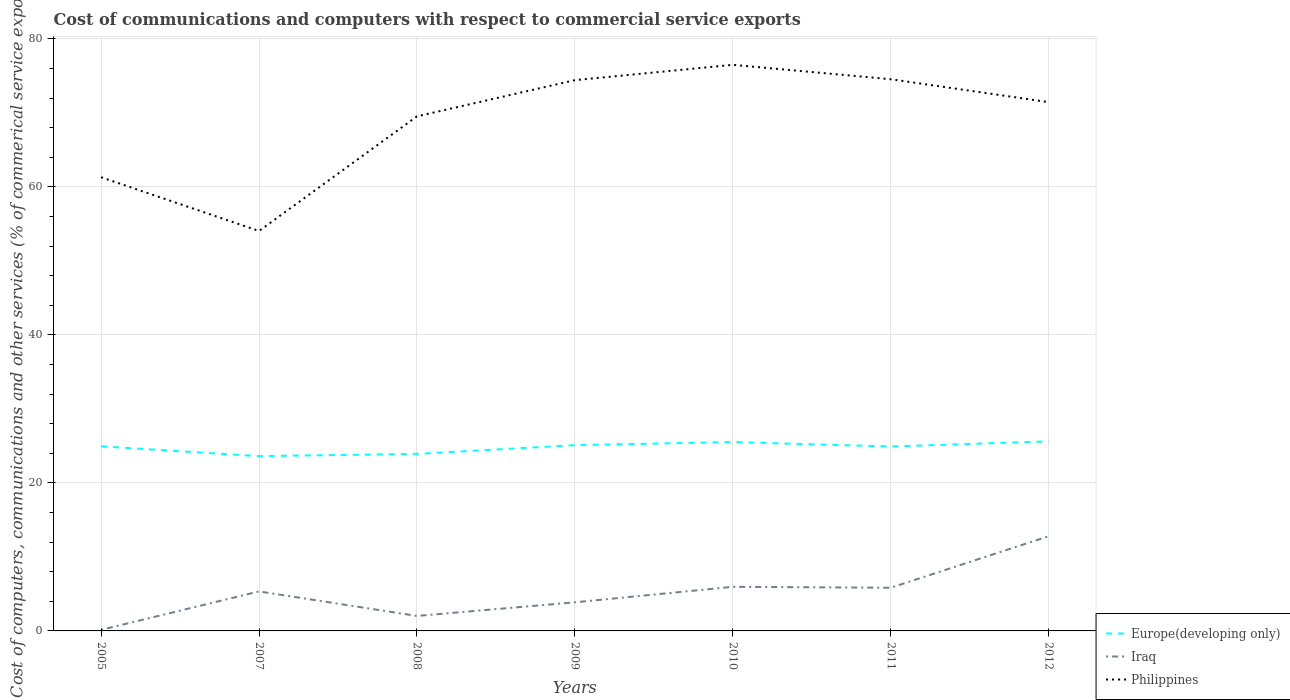Across all years, what is the maximum cost of communications and computers in Philippines?
Offer a very short reply. 54.05. In which year was the cost of communications and computers in Iraq maximum?
Ensure brevity in your answer.  2005. What is the total cost of communications and computers in Iraq in the graph?
Your answer should be compact. -6.96. What is the difference between the highest and the second highest cost of communications and computers in Europe(developing only)?
Keep it short and to the point. 2. Are the values on the major ticks of Y-axis written in scientific E-notation?
Offer a very short reply. No. Does the graph contain any zero values?
Provide a short and direct response. No. How many legend labels are there?
Ensure brevity in your answer.  3. How are the legend labels stacked?
Provide a short and direct response. Vertical. What is the title of the graph?
Offer a terse response. Cost of communications and computers with respect to commercial service exports. Does "Singapore" appear as one of the legend labels in the graph?
Your answer should be very brief. No. What is the label or title of the Y-axis?
Keep it short and to the point. Cost of computers, communications and other services (% of commerical service exports). What is the Cost of computers, communications and other services (% of commerical service exports) in Europe(developing only) in 2005?
Give a very brief answer. 24.95. What is the Cost of computers, communications and other services (% of commerical service exports) in Iraq in 2005?
Provide a short and direct response. 0.14. What is the Cost of computers, communications and other services (% of commerical service exports) in Philippines in 2005?
Your answer should be compact. 61.31. What is the Cost of computers, communications and other services (% of commerical service exports) in Europe(developing only) in 2007?
Offer a very short reply. 23.62. What is the Cost of computers, communications and other services (% of commerical service exports) in Iraq in 2007?
Give a very brief answer. 5.34. What is the Cost of computers, communications and other services (% of commerical service exports) in Philippines in 2007?
Offer a terse response. 54.05. What is the Cost of computers, communications and other services (% of commerical service exports) of Europe(developing only) in 2008?
Ensure brevity in your answer.  23.93. What is the Cost of computers, communications and other services (% of commerical service exports) in Iraq in 2008?
Your answer should be compact. 2.03. What is the Cost of computers, communications and other services (% of commerical service exports) of Philippines in 2008?
Your answer should be very brief. 69.54. What is the Cost of computers, communications and other services (% of commerical service exports) in Europe(developing only) in 2009?
Offer a very short reply. 25.11. What is the Cost of computers, communications and other services (% of commerical service exports) in Iraq in 2009?
Your answer should be compact. 3.87. What is the Cost of computers, communications and other services (% of commerical service exports) in Philippines in 2009?
Offer a terse response. 74.43. What is the Cost of computers, communications and other services (% of commerical service exports) of Europe(developing only) in 2010?
Provide a succinct answer. 25.52. What is the Cost of computers, communications and other services (% of commerical service exports) in Iraq in 2010?
Your response must be concise. 5.96. What is the Cost of computers, communications and other services (% of commerical service exports) in Philippines in 2010?
Offer a terse response. 76.5. What is the Cost of computers, communications and other services (% of commerical service exports) in Europe(developing only) in 2011?
Make the answer very short. 24.93. What is the Cost of computers, communications and other services (% of commerical service exports) in Iraq in 2011?
Give a very brief answer. 5.84. What is the Cost of computers, communications and other services (% of commerical service exports) of Philippines in 2011?
Give a very brief answer. 74.56. What is the Cost of computers, communications and other services (% of commerical service exports) in Europe(developing only) in 2012?
Your response must be concise. 25.62. What is the Cost of computers, communications and other services (% of commerical service exports) in Iraq in 2012?
Give a very brief answer. 12.8. What is the Cost of computers, communications and other services (% of commerical service exports) in Philippines in 2012?
Your answer should be very brief. 71.46. Across all years, what is the maximum Cost of computers, communications and other services (% of commerical service exports) of Europe(developing only)?
Your response must be concise. 25.62. Across all years, what is the maximum Cost of computers, communications and other services (% of commerical service exports) of Iraq?
Your answer should be very brief. 12.8. Across all years, what is the maximum Cost of computers, communications and other services (% of commerical service exports) in Philippines?
Your response must be concise. 76.5. Across all years, what is the minimum Cost of computers, communications and other services (% of commerical service exports) in Europe(developing only)?
Make the answer very short. 23.62. Across all years, what is the minimum Cost of computers, communications and other services (% of commerical service exports) in Iraq?
Offer a terse response. 0.14. Across all years, what is the minimum Cost of computers, communications and other services (% of commerical service exports) of Philippines?
Offer a very short reply. 54.05. What is the total Cost of computers, communications and other services (% of commerical service exports) of Europe(developing only) in the graph?
Your answer should be very brief. 173.67. What is the total Cost of computers, communications and other services (% of commerical service exports) in Iraq in the graph?
Ensure brevity in your answer.  35.97. What is the total Cost of computers, communications and other services (% of commerical service exports) of Philippines in the graph?
Offer a very short reply. 481.86. What is the difference between the Cost of computers, communications and other services (% of commerical service exports) of Europe(developing only) in 2005 and that in 2007?
Offer a terse response. 1.33. What is the difference between the Cost of computers, communications and other services (% of commerical service exports) of Iraq in 2005 and that in 2007?
Keep it short and to the point. -5.19. What is the difference between the Cost of computers, communications and other services (% of commerical service exports) of Philippines in 2005 and that in 2007?
Keep it short and to the point. 7.27. What is the difference between the Cost of computers, communications and other services (% of commerical service exports) in Europe(developing only) in 2005 and that in 2008?
Offer a terse response. 1.02. What is the difference between the Cost of computers, communications and other services (% of commerical service exports) of Iraq in 2005 and that in 2008?
Your answer should be very brief. -1.88. What is the difference between the Cost of computers, communications and other services (% of commerical service exports) of Philippines in 2005 and that in 2008?
Offer a terse response. -8.23. What is the difference between the Cost of computers, communications and other services (% of commerical service exports) of Europe(developing only) in 2005 and that in 2009?
Ensure brevity in your answer.  -0.16. What is the difference between the Cost of computers, communications and other services (% of commerical service exports) in Iraq in 2005 and that in 2009?
Your answer should be very brief. -3.72. What is the difference between the Cost of computers, communications and other services (% of commerical service exports) in Philippines in 2005 and that in 2009?
Your answer should be very brief. -13.12. What is the difference between the Cost of computers, communications and other services (% of commerical service exports) of Europe(developing only) in 2005 and that in 2010?
Your answer should be compact. -0.58. What is the difference between the Cost of computers, communications and other services (% of commerical service exports) in Iraq in 2005 and that in 2010?
Keep it short and to the point. -5.82. What is the difference between the Cost of computers, communications and other services (% of commerical service exports) of Philippines in 2005 and that in 2010?
Keep it short and to the point. -15.19. What is the difference between the Cost of computers, communications and other services (% of commerical service exports) of Europe(developing only) in 2005 and that in 2011?
Your answer should be compact. 0.02. What is the difference between the Cost of computers, communications and other services (% of commerical service exports) of Iraq in 2005 and that in 2011?
Give a very brief answer. -5.69. What is the difference between the Cost of computers, communications and other services (% of commerical service exports) in Philippines in 2005 and that in 2011?
Provide a short and direct response. -13.24. What is the difference between the Cost of computers, communications and other services (% of commerical service exports) in Europe(developing only) in 2005 and that in 2012?
Give a very brief answer. -0.67. What is the difference between the Cost of computers, communications and other services (% of commerical service exports) in Iraq in 2005 and that in 2012?
Provide a succinct answer. -12.65. What is the difference between the Cost of computers, communications and other services (% of commerical service exports) of Philippines in 2005 and that in 2012?
Offer a terse response. -10.15. What is the difference between the Cost of computers, communications and other services (% of commerical service exports) in Europe(developing only) in 2007 and that in 2008?
Give a very brief answer. -0.31. What is the difference between the Cost of computers, communications and other services (% of commerical service exports) of Iraq in 2007 and that in 2008?
Give a very brief answer. 3.31. What is the difference between the Cost of computers, communications and other services (% of commerical service exports) in Philippines in 2007 and that in 2008?
Offer a very short reply. -15.49. What is the difference between the Cost of computers, communications and other services (% of commerical service exports) of Europe(developing only) in 2007 and that in 2009?
Provide a succinct answer. -1.49. What is the difference between the Cost of computers, communications and other services (% of commerical service exports) of Iraq in 2007 and that in 2009?
Offer a terse response. 1.47. What is the difference between the Cost of computers, communications and other services (% of commerical service exports) in Philippines in 2007 and that in 2009?
Give a very brief answer. -20.38. What is the difference between the Cost of computers, communications and other services (% of commerical service exports) of Europe(developing only) in 2007 and that in 2010?
Provide a short and direct response. -1.9. What is the difference between the Cost of computers, communications and other services (% of commerical service exports) in Iraq in 2007 and that in 2010?
Your answer should be compact. -0.62. What is the difference between the Cost of computers, communications and other services (% of commerical service exports) of Philippines in 2007 and that in 2010?
Your answer should be compact. -22.46. What is the difference between the Cost of computers, communications and other services (% of commerical service exports) in Europe(developing only) in 2007 and that in 2011?
Offer a terse response. -1.3. What is the difference between the Cost of computers, communications and other services (% of commerical service exports) of Iraq in 2007 and that in 2011?
Give a very brief answer. -0.5. What is the difference between the Cost of computers, communications and other services (% of commerical service exports) of Philippines in 2007 and that in 2011?
Your response must be concise. -20.51. What is the difference between the Cost of computers, communications and other services (% of commerical service exports) of Europe(developing only) in 2007 and that in 2012?
Make the answer very short. -2. What is the difference between the Cost of computers, communications and other services (% of commerical service exports) of Iraq in 2007 and that in 2012?
Keep it short and to the point. -7.46. What is the difference between the Cost of computers, communications and other services (% of commerical service exports) in Philippines in 2007 and that in 2012?
Your answer should be compact. -17.41. What is the difference between the Cost of computers, communications and other services (% of commerical service exports) of Europe(developing only) in 2008 and that in 2009?
Give a very brief answer. -1.18. What is the difference between the Cost of computers, communications and other services (% of commerical service exports) in Iraq in 2008 and that in 2009?
Make the answer very short. -1.84. What is the difference between the Cost of computers, communications and other services (% of commerical service exports) in Philippines in 2008 and that in 2009?
Make the answer very short. -4.89. What is the difference between the Cost of computers, communications and other services (% of commerical service exports) in Europe(developing only) in 2008 and that in 2010?
Your answer should be very brief. -1.6. What is the difference between the Cost of computers, communications and other services (% of commerical service exports) of Iraq in 2008 and that in 2010?
Provide a succinct answer. -3.94. What is the difference between the Cost of computers, communications and other services (% of commerical service exports) in Philippines in 2008 and that in 2010?
Offer a very short reply. -6.96. What is the difference between the Cost of computers, communications and other services (% of commerical service exports) of Europe(developing only) in 2008 and that in 2011?
Give a very brief answer. -1. What is the difference between the Cost of computers, communications and other services (% of commerical service exports) of Iraq in 2008 and that in 2011?
Ensure brevity in your answer.  -3.81. What is the difference between the Cost of computers, communications and other services (% of commerical service exports) in Philippines in 2008 and that in 2011?
Your answer should be very brief. -5.02. What is the difference between the Cost of computers, communications and other services (% of commerical service exports) in Europe(developing only) in 2008 and that in 2012?
Make the answer very short. -1.69. What is the difference between the Cost of computers, communications and other services (% of commerical service exports) in Iraq in 2008 and that in 2012?
Give a very brief answer. -10.77. What is the difference between the Cost of computers, communications and other services (% of commerical service exports) of Philippines in 2008 and that in 2012?
Offer a terse response. -1.92. What is the difference between the Cost of computers, communications and other services (% of commerical service exports) of Europe(developing only) in 2009 and that in 2010?
Ensure brevity in your answer.  -0.42. What is the difference between the Cost of computers, communications and other services (% of commerical service exports) of Iraq in 2009 and that in 2010?
Keep it short and to the point. -2.09. What is the difference between the Cost of computers, communications and other services (% of commerical service exports) in Philippines in 2009 and that in 2010?
Offer a very short reply. -2.07. What is the difference between the Cost of computers, communications and other services (% of commerical service exports) of Europe(developing only) in 2009 and that in 2011?
Give a very brief answer. 0.18. What is the difference between the Cost of computers, communications and other services (% of commerical service exports) in Iraq in 2009 and that in 2011?
Ensure brevity in your answer.  -1.97. What is the difference between the Cost of computers, communications and other services (% of commerical service exports) in Philippines in 2009 and that in 2011?
Give a very brief answer. -0.12. What is the difference between the Cost of computers, communications and other services (% of commerical service exports) in Europe(developing only) in 2009 and that in 2012?
Offer a terse response. -0.51. What is the difference between the Cost of computers, communications and other services (% of commerical service exports) of Iraq in 2009 and that in 2012?
Your response must be concise. -8.93. What is the difference between the Cost of computers, communications and other services (% of commerical service exports) in Philippines in 2009 and that in 2012?
Ensure brevity in your answer.  2.97. What is the difference between the Cost of computers, communications and other services (% of commerical service exports) in Europe(developing only) in 2010 and that in 2011?
Provide a short and direct response. 0.6. What is the difference between the Cost of computers, communications and other services (% of commerical service exports) of Iraq in 2010 and that in 2011?
Give a very brief answer. 0.13. What is the difference between the Cost of computers, communications and other services (% of commerical service exports) of Philippines in 2010 and that in 2011?
Offer a very short reply. 1.95. What is the difference between the Cost of computers, communications and other services (% of commerical service exports) of Europe(developing only) in 2010 and that in 2012?
Provide a succinct answer. -0.1. What is the difference between the Cost of computers, communications and other services (% of commerical service exports) of Iraq in 2010 and that in 2012?
Offer a very short reply. -6.83. What is the difference between the Cost of computers, communications and other services (% of commerical service exports) in Philippines in 2010 and that in 2012?
Your answer should be compact. 5.04. What is the difference between the Cost of computers, communications and other services (% of commerical service exports) of Europe(developing only) in 2011 and that in 2012?
Keep it short and to the point. -0.69. What is the difference between the Cost of computers, communications and other services (% of commerical service exports) in Iraq in 2011 and that in 2012?
Provide a succinct answer. -6.96. What is the difference between the Cost of computers, communications and other services (% of commerical service exports) in Philippines in 2011 and that in 2012?
Ensure brevity in your answer.  3.1. What is the difference between the Cost of computers, communications and other services (% of commerical service exports) of Europe(developing only) in 2005 and the Cost of computers, communications and other services (% of commerical service exports) of Iraq in 2007?
Your response must be concise. 19.61. What is the difference between the Cost of computers, communications and other services (% of commerical service exports) of Europe(developing only) in 2005 and the Cost of computers, communications and other services (% of commerical service exports) of Philippines in 2007?
Your answer should be compact. -29.1. What is the difference between the Cost of computers, communications and other services (% of commerical service exports) of Iraq in 2005 and the Cost of computers, communications and other services (% of commerical service exports) of Philippines in 2007?
Ensure brevity in your answer.  -53.91. What is the difference between the Cost of computers, communications and other services (% of commerical service exports) in Europe(developing only) in 2005 and the Cost of computers, communications and other services (% of commerical service exports) in Iraq in 2008?
Provide a succinct answer. 22.92. What is the difference between the Cost of computers, communications and other services (% of commerical service exports) in Europe(developing only) in 2005 and the Cost of computers, communications and other services (% of commerical service exports) in Philippines in 2008?
Provide a short and direct response. -44.59. What is the difference between the Cost of computers, communications and other services (% of commerical service exports) of Iraq in 2005 and the Cost of computers, communications and other services (% of commerical service exports) of Philippines in 2008?
Give a very brief answer. -69.4. What is the difference between the Cost of computers, communications and other services (% of commerical service exports) of Europe(developing only) in 2005 and the Cost of computers, communications and other services (% of commerical service exports) of Iraq in 2009?
Provide a short and direct response. 21.08. What is the difference between the Cost of computers, communications and other services (% of commerical service exports) of Europe(developing only) in 2005 and the Cost of computers, communications and other services (% of commerical service exports) of Philippines in 2009?
Your response must be concise. -49.49. What is the difference between the Cost of computers, communications and other services (% of commerical service exports) of Iraq in 2005 and the Cost of computers, communications and other services (% of commerical service exports) of Philippines in 2009?
Provide a succinct answer. -74.29. What is the difference between the Cost of computers, communications and other services (% of commerical service exports) of Europe(developing only) in 2005 and the Cost of computers, communications and other services (% of commerical service exports) of Iraq in 2010?
Keep it short and to the point. 18.99. What is the difference between the Cost of computers, communications and other services (% of commerical service exports) in Europe(developing only) in 2005 and the Cost of computers, communications and other services (% of commerical service exports) in Philippines in 2010?
Offer a terse response. -51.56. What is the difference between the Cost of computers, communications and other services (% of commerical service exports) of Iraq in 2005 and the Cost of computers, communications and other services (% of commerical service exports) of Philippines in 2010?
Make the answer very short. -76.36. What is the difference between the Cost of computers, communications and other services (% of commerical service exports) of Europe(developing only) in 2005 and the Cost of computers, communications and other services (% of commerical service exports) of Iraq in 2011?
Keep it short and to the point. 19.11. What is the difference between the Cost of computers, communications and other services (% of commerical service exports) of Europe(developing only) in 2005 and the Cost of computers, communications and other services (% of commerical service exports) of Philippines in 2011?
Make the answer very short. -49.61. What is the difference between the Cost of computers, communications and other services (% of commerical service exports) in Iraq in 2005 and the Cost of computers, communications and other services (% of commerical service exports) in Philippines in 2011?
Keep it short and to the point. -74.41. What is the difference between the Cost of computers, communications and other services (% of commerical service exports) of Europe(developing only) in 2005 and the Cost of computers, communications and other services (% of commerical service exports) of Iraq in 2012?
Ensure brevity in your answer.  12.15. What is the difference between the Cost of computers, communications and other services (% of commerical service exports) of Europe(developing only) in 2005 and the Cost of computers, communications and other services (% of commerical service exports) of Philippines in 2012?
Keep it short and to the point. -46.51. What is the difference between the Cost of computers, communications and other services (% of commerical service exports) in Iraq in 2005 and the Cost of computers, communications and other services (% of commerical service exports) in Philippines in 2012?
Give a very brief answer. -71.32. What is the difference between the Cost of computers, communications and other services (% of commerical service exports) in Europe(developing only) in 2007 and the Cost of computers, communications and other services (% of commerical service exports) in Iraq in 2008?
Your response must be concise. 21.59. What is the difference between the Cost of computers, communications and other services (% of commerical service exports) in Europe(developing only) in 2007 and the Cost of computers, communications and other services (% of commerical service exports) in Philippines in 2008?
Offer a terse response. -45.92. What is the difference between the Cost of computers, communications and other services (% of commerical service exports) in Iraq in 2007 and the Cost of computers, communications and other services (% of commerical service exports) in Philippines in 2008?
Make the answer very short. -64.2. What is the difference between the Cost of computers, communications and other services (% of commerical service exports) in Europe(developing only) in 2007 and the Cost of computers, communications and other services (% of commerical service exports) in Iraq in 2009?
Your response must be concise. 19.75. What is the difference between the Cost of computers, communications and other services (% of commerical service exports) in Europe(developing only) in 2007 and the Cost of computers, communications and other services (% of commerical service exports) in Philippines in 2009?
Offer a terse response. -50.81. What is the difference between the Cost of computers, communications and other services (% of commerical service exports) of Iraq in 2007 and the Cost of computers, communications and other services (% of commerical service exports) of Philippines in 2009?
Your answer should be compact. -69.1. What is the difference between the Cost of computers, communications and other services (% of commerical service exports) in Europe(developing only) in 2007 and the Cost of computers, communications and other services (% of commerical service exports) in Iraq in 2010?
Your answer should be very brief. 17.66. What is the difference between the Cost of computers, communications and other services (% of commerical service exports) of Europe(developing only) in 2007 and the Cost of computers, communications and other services (% of commerical service exports) of Philippines in 2010?
Provide a succinct answer. -52.88. What is the difference between the Cost of computers, communications and other services (% of commerical service exports) of Iraq in 2007 and the Cost of computers, communications and other services (% of commerical service exports) of Philippines in 2010?
Your answer should be compact. -71.17. What is the difference between the Cost of computers, communications and other services (% of commerical service exports) in Europe(developing only) in 2007 and the Cost of computers, communications and other services (% of commerical service exports) in Iraq in 2011?
Provide a short and direct response. 17.78. What is the difference between the Cost of computers, communications and other services (% of commerical service exports) in Europe(developing only) in 2007 and the Cost of computers, communications and other services (% of commerical service exports) in Philippines in 2011?
Offer a terse response. -50.94. What is the difference between the Cost of computers, communications and other services (% of commerical service exports) of Iraq in 2007 and the Cost of computers, communications and other services (% of commerical service exports) of Philippines in 2011?
Give a very brief answer. -69.22. What is the difference between the Cost of computers, communications and other services (% of commerical service exports) in Europe(developing only) in 2007 and the Cost of computers, communications and other services (% of commerical service exports) in Iraq in 2012?
Offer a very short reply. 10.82. What is the difference between the Cost of computers, communications and other services (% of commerical service exports) in Europe(developing only) in 2007 and the Cost of computers, communications and other services (% of commerical service exports) in Philippines in 2012?
Your answer should be compact. -47.84. What is the difference between the Cost of computers, communications and other services (% of commerical service exports) of Iraq in 2007 and the Cost of computers, communications and other services (% of commerical service exports) of Philippines in 2012?
Provide a succinct answer. -66.12. What is the difference between the Cost of computers, communications and other services (% of commerical service exports) of Europe(developing only) in 2008 and the Cost of computers, communications and other services (% of commerical service exports) of Iraq in 2009?
Offer a very short reply. 20.06. What is the difference between the Cost of computers, communications and other services (% of commerical service exports) in Europe(developing only) in 2008 and the Cost of computers, communications and other services (% of commerical service exports) in Philippines in 2009?
Your response must be concise. -50.51. What is the difference between the Cost of computers, communications and other services (% of commerical service exports) of Iraq in 2008 and the Cost of computers, communications and other services (% of commerical service exports) of Philippines in 2009?
Offer a very short reply. -72.41. What is the difference between the Cost of computers, communications and other services (% of commerical service exports) of Europe(developing only) in 2008 and the Cost of computers, communications and other services (% of commerical service exports) of Iraq in 2010?
Your answer should be very brief. 17.97. What is the difference between the Cost of computers, communications and other services (% of commerical service exports) in Europe(developing only) in 2008 and the Cost of computers, communications and other services (% of commerical service exports) in Philippines in 2010?
Provide a short and direct response. -52.58. What is the difference between the Cost of computers, communications and other services (% of commerical service exports) of Iraq in 2008 and the Cost of computers, communications and other services (% of commerical service exports) of Philippines in 2010?
Your response must be concise. -74.48. What is the difference between the Cost of computers, communications and other services (% of commerical service exports) of Europe(developing only) in 2008 and the Cost of computers, communications and other services (% of commerical service exports) of Iraq in 2011?
Your response must be concise. 18.09. What is the difference between the Cost of computers, communications and other services (% of commerical service exports) of Europe(developing only) in 2008 and the Cost of computers, communications and other services (% of commerical service exports) of Philippines in 2011?
Your response must be concise. -50.63. What is the difference between the Cost of computers, communications and other services (% of commerical service exports) in Iraq in 2008 and the Cost of computers, communications and other services (% of commerical service exports) in Philippines in 2011?
Provide a succinct answer. -72.53. What is the difference between the Cost of computers, communications and other services (% of commerical service exports) in Europe(developing only) in 2008 and the Cost of computers, communications and other services (% of commerical service exports) in Iraq in 2012?
Your response must be concise. 11.13. What is the difference between the Cost of computers, communications and other services (% of commerical service exports) of Europe(developing only) in 2008 and the Cost of computers, communications and other services (% of commerical service exports) of Philippines in 2012?
Ensure brevity in your answer.  -47.53. What is the difference between the Cost of computers, communications and other services (% of commerical service exports) in Iraq in 2008 and the Cost of computers, communications and other services (% of commerical service exports) in Philippines in 2012?
Your answer should be compact. -69.43. What is the difference between the Cost of computers, communications and other services (% of commerical service exports) of Europe(developing only) in 2009 and the Cost of computers, communications and other services (% of commerical service exports) of Iraq in 2010?
Offer a terse response. 19.14. What is the difference between the Cost of computers, communications and other services (% of commerical service exports) of Europe(developing only) in 2009 and the Cost of computers, communications and other services (% of commerical service exports) of Philippines in 2010?
Your answer should be very brief. -51.4. What is the difference between the Cost of computers, communications and other services (% of commerical service exports) of Iraq in 2009 and the Cost of computers, communications and other services (% of commerical service exports) of Philippines in 2010?
Offer a very short reply. -72.64. What is the difference between the Cost of computers, communications and other services (% of commerical service exports) of Europe(developing only) in 2009 and the Cost of computers, communications and other services (% of commerical service exports) of Iraq in 2011?
Ensure brevity in your answer.  19.27. What is the difference between the Cost of computers, communications and other services (% of commerical service exports) in Europe(developing only) in 2009 and the Cost of computers, communications and other services (% of commerical service exports) in Philippines in 2011?
Offer a terse response. -49.45. What is the difference between the Cost of computers, communications and other services (% of commerical service exports) in Iraq in 2009 and the Cost of computers, communications and other services (% of commerical service exports) in Philippines in 2011?
Offer a very short reply. -70.69. What is the difference between the Cost of computers, communications and other services (% of commerical service exports) of Europe(developing only) in 2009 and the Cost of computers, communications and other services (% of commerical service exports) of Iraq in 2012?
Provide a short and direct response. 12.31. What is the difference between the Cost of computers, communications and other services (% of commerical service exports) of Europe(developing only) in 2009 and the Cost of computers, communications and other services (% of commerical service exports) of Philippines in 2012?
Keep it short and to the point. -46.35. What is the difference between the Cost of computers, communications and other services (% of commerical service exports) in Iraq in 2009 and the Cost of computers, communications and other services (% of commerical service exports) in Philippines in 2012?
Ensure brevity in your answer.  -67.59. What is the difference between the Cost of computers, communications and other services (% of commerical service exports) in Europe(developing only) in 2010 and the Cost of computers, communications and other services (% of commerical service exports) in Iraq in 2011?
Provide a short and direct response. 19.69. What is the difference between the Cost of computers, communications and other services (% of commerical service exports) of Europe(developing only) in 2010 and the Cost of computers, communications and other services (% of commerical service exports) of Philippines in 2011?
Offer a very short reply. -49.03. What is the difference between the Cost of computers, communications and other services (% of commerical service exports) of Iraq in 2010 and the Cost of computers, communications and other services (% of commerical service exports) of Philippines in 2011?
Give a very brief answer. -68.6. What is the difference between the Cost of computers, communications and other services (% of commerical service exports) of Europe(developing only) in 2010 and the Cost of computers, communications and other services (% of commerical service exports) of Iraq in 2012?
Ensure brevity in your answer.  12.73. What is the difference between the Cost of computers, communications and other services (% of commerical service exports) of Europe(developing only) in 2010 and the Cost of computers, communications and other services (% of commerical service exports) of Philippines in 2012?
Provide a succinct answer. -45.94. What is the difference between the Cost of computers, communications and other services (% of commerical service exports) in Iraq in 2010 and the Cost of computers, communications and other services (% of commerical service exports) in Philippines in 2012?
Offer a terse response. -65.5. What is the difference between the Cost of computers, communications and other services (% of commerical service exports) of Europe(developing only) in 2011 and the Cost of computers, communications and other services (% of commerical service exports) of Iraq in 2012?
Your answer should be very brief. 12.13. What is the difference between the Cost of computers, communications and other services (% of commerical service exports) of Europe(developing only) in 2011 and the Cost of computers, communications and other services (% of commerical service exports) of Philippines in 2012?
Your answer should be compact. -46.53. What is the difference between the Cost of computers, communications and other services (% of commerical service exports) of Iraq in 2011 and the Cost of computers, communications and other services (% of commerical service exports) of Philippines in 2012?
Provide a succinct answer. -65.62. What is the average Cost of computers, communications and other services (% of commerical service exports) in Europe(developing only) per year?
Keep it short and to the point. 24.81. What is the average Cost of computers, communications and other services (% of commerical service exports) of Iraq per year?
Your response must be concise. 5.14. What is the average Cost of computers, communications and other services (% of commerical service exports) in Philippines per year?
Keep it short and to the point. 68.84. In the year 2005, what is the difference between the Cost of computers, communications and other services (% of commerical service exports) of Europe(developing only) and Cost of computers, communications and other services (% of commerical service exports) of Iraq?
Your answer should be compact. 24.8. In the year 2005, what is the difference between the Cost of computers, communications and other services (% of commerical service exports) of Europe(developing only) and Cost of computers, communications and other services (% of commerical service exports) of Philippines?
Offer a terse response. -36.37. In the year 2005, what is the difference between the Cost of computers, communications and other services (% of commerical service exports) of Iraq and Cost of computers, communications and other services (% of commerical service exports) of Philippines?
Make the answer very short. -61.17. In the year 2007, what is the difference between the Cost of computers, communications and other services (% of commerical service exports) of Europe(developing only) and Cost of computers, communications and other services (% of commerical service exports) of Iraq?
Provide a short and direct response. 18.28. In the year 2007, what is the difference between the Cost of computers, communications and other services (% of commerical service exports) of Europe(developing only) and Cost of computers, communications and other services (% of commerical service exports) of Philippines?
Provide a succinct answer. -30.43. In the year 2007, what is the difference between the Cost of computers, communications and other services (% of commerical service exports) in Iraq and Cost of computers, communications and other services (% of commerical service exports) in Philippines?
Your response must be concise. -48.71. In the year 2008, what is the difference between the Cost of computers, communications and other services (% of commerical service exports) of Europe(developing only) and Cost of computers, communications and other services (% of commerical service exports) of Iraq?
Your answer should be very brief. 21.9. In the year 2008, what is the difference between the Cost of computers, communications and other services (% of commerical service exports) of Europe(developing only) and Cost of computers, communications and other services (% of commerical service exports) of Philippines?
Provide a short and direct response. -45.61. In the year 2008, what is the difference between the Cost of computers, communications and other services (% of commerical service exports) in Iraq and Cost of computers, communications and other services (% of commerical service exports) in Philippines?
Your answer should be very brief. -67.51. In the year 2009, what is the difference between the Cost of computers, communications and other services (% of commerical service exports) in Europe(developing only) and Cost of computers, communications and other services (% of commerical service exports) in Iraq?
Keep it short and to the point. 21.24. In the year 2009, what is the difference between the Cost of computers, communications and other services (% of commerical service exports) in Europe(developing only) and Cost of computers, communications and other services (% of commerical service exports) in Philippines?
Provide a short and direct response. -49.33. In the year 2009, what is the difference between the Cost of computers, communications and other services (% of commerical service exports) in Iraq and Cost of computers, communications and other services (% of commerical service exports) in Philippines?
Ensure brevity in your answer.  -70.57. In the year 2010, what is the difference between the Cost of computers, communications and other services (% of commerical service exports) in Europe(developing only) and Cost of computers, communications and other services (% of commerical service exports) in Iraq?
Offer a very short reply. 19.56. In the year 2010, what is the difference between the Cost of computers, communications and other services (% of commerical service exports) in Europe(developing only) and Cost of computers, communications and other services (% of commerical service exports) in Philippines?
Your answer should be very brief. -50.98. In the year 2010, what is the difference between the Cost of computers, communications and other services (% of commerical service exports) in Iraq and Cost of computers, communications and other services (% of commerical service exports) in Philippines?
Give a very brief answer. -70.54. In the year 2011, what is the difference between the Cost of computers, communications and other services (% of commerical service exports) of Europe(developing only) and Cost of computers, communications and other services (% of commerical service exports) of Iraq?
Ensure brevity in your answer.  19.09. In the year 2011, what is the difference between the Cost of computers, communications and other services (% of commerical service exports) of Europe(developing only) and Cost of computers, communications and other services (% of commerical service exports) of Philippines?
Make the answer very short. -49.63. In the year 2011, what is the difference between the Cost of computers, communications and other services (% of commerical service exports) of Iraq and Cost of computers, communications and other services (% of commerical service exports) of Philippines?
Offer a terse response. -68.72. In the year 2012, what is the difference between the Cost of computers, communications and other services (% of commerical service exports) of Europe(developing only) and Cost of computers, communications and other services (% of commerical service exports) of Iraq?
Your answer should be compact. 12.82. In the year 2012, what is the difference between the Cost of computers, communications and other services (% of commerical service exports) in Europe(developing only) and Cost of computers, communications and other services (% of commerical service exports) in Philippines?
Keep it short and to the point. -45.84. In the year 2012, what is the difference between the Cost of computers, communications and other services (% of commerical service exports) in Iraq and Cost of computers, communications and other services (% of commerical service exports) in Philippines?
Ensure brevity in your answer.  -58.66. What is the ratio of the Cost of computers, communications and other services (% of commerical service exports) of Europe(developing only) in 2005 to that in 2007?
Your answer should be very brief. 1.06. What is the ratio of the Cost of computers, communications and other services (% of commerical service exports) in Iraq in 2005 to that in 2007?
Provide a short and direct response. 0.03. What is the ratio of the Cost of computers, communications and other services (% of commerical service exports) of Philippines in 2005 to that in 2007?
Give a very brief answer. 1.13. What is the ratio of the Cost of computers, communications and other services (% of commerical service exports) of Europe(developing only) in 2005 to that in 2008?
Keep it short and to the point. 1.04. What is the ratio of the Cost of computers, communications and other services (% of commerical service exports) in Iraq in 2005 to that in 2008?
Provide a succinct answer. 0.07. What is the ratio of the Cost of computers, communications and other services (% of commerical service exports) of Philippines in 2005 to that in 2008?
Ensure brevity in your answer.  0.88. What is the ratio of the Cost of computers, communications and other services (% of commerical service exports) of Iraq in 2005 to that in 2009?
Your answer should be very brief. 0.04. What is the ratio of the Cost of computers, communications and other services (% of commerical service exports) in Philippines in 2005 to that in 2009?
Offer a terse response. 0.82. What is the ratio of the Cost of computers, communications and other services (% of commerical service exports) of Europe(developing only) in 2005 to that in 2010?
Your answer should be very brief. 0.98. What is the ratio of the Cost of computers, communications and other services (% of commerical service exports) of Iraq in 2005 to that in 2010?
Your answer should be compact. 0.02. What is the ratio of the Cost of computers, communications and other services (% of commerical service exports) of Philippines in 2005 to that in 2010?
Provide a short and direct response. 0.8. What is the ratio of the Cost of computers, communications and other services (% of commerical service exports) of Iraq in 2005 to that in 2011?
Your answer should be compact. 0.02. What is the ratio of the Cost of computers, communications and other services (% of commerical service exports) in Philippines in 2005 to that in 2011?
Give a very brief answer. 0.82. What is the ratio of the Cost of computers, communications and other services (% of commerical service exports) of Europe(developing only) in 2005 to that in 2012?
Give a very brief answer. 0.97. What is the ratio of the Cost of computers, communications and other services (% of commerical service exports) in Iraq in 2005 to that in 2012?
Ensure brevity in your answer.  0.01. What is the ratio of the Cost of computers, communications and other services (% of commerical service exports) in Philippines in 2005 to that in 2012?
Give a very brief answer. 0.86. What is the ratio of the Cost of computers, communications and other services (% of commerical service exports) of Europe(developing only) in 2007 to that in 2008?
Offer a very short reply. 0.99. What is the ratio of the Cost of computers, communications and other services (% of commerical service exports) in Iraq in 2007 to that in 2008?
Offer a terse response. 2.64. What is the ratio of the Cost of computers, communications and other services (% of commerical service exports) in Philippines in 2007 to that in 2008?
Your answer should be very brief. 0.78. What is the ratio of the Cost of computers, communications and other services (% of commerical service exports) in Europe(developing only) in 2007 to that in 2009?
Provide a succinct answer. 0.94. What is the ratio of the Cost of computers, communications and other services (% of commerical service exports) of Iraq in 2007 to that in 2009?
Your answer should be very brief. 1.38. What is the ratio of the Cost of computers, communications and other services (% of commerical service exports) of Philippines in 2007 to that in 2009?
Your answer should be compact. 0.73. What is the ratio of the Cost of computers, communications and other services (% of commerical service exports) in Europe(developing only) in 2007 to that in 2010?
Offer a terse response. 0.93. What is the ratio of the Cost of computers, communications and other services (% of commerical service exports) of Iraq in 2007 to that in 2010?
Offer a terse response. 0.9. What is the ratio of the Cost of computers, communications and other services (% of commerical service exports) in Philippines in 2007 to that in 2010?
Offer a very short reply. 0.71. What is the ratio of the Cost of computers, communications and other services (% of commerical service exports) in Europe(developing only) in 2007 to that in 2011?
Your response must be concise. 0.95. What is the ratio of the Cost of computers, communications and other services (% of commerical service exports) in Iraq in 2007 to that in 2011?
Provide a succinct answer. 0.91. What is the ratio of the Cost of computers, communications and other services (% of commerical service exports) in Philippines in 2007 to that in 2011?
Keep it short and to the point. 0.72. What is the ratio of the Cost of computers, communications and other services (% of commerical service exports) of Europe(developing only) in 2007 to that in 2012?
Your response must be concise. 0.92. What is the ratio of the Cost of computers, communications and other services (% of commerical service exports) in Iraq in 2007 to that in 2012?
Offer a very short reply. 0.42. What is the ratio of the Cost of computers, communications and other services (% of commerical service exports) of Philippines in 2007 to that in 2012?
Offer a terse response. 0.76. What is the ratio of the Cost of computers, communications and other services (% of commerical service exports) in Europe(developing only) in 2008 to that in 2009?
Ensure brevity in your answer.  0.95. What is the ratio of the Cost of computers, communications and other services (% of commerical service exports) of Iraq in 2008 to that in 2009?
Give a very brief answer. 0.52. What is the ratio of the Cost of computers, communications and other services (% of commerical service exports) of Philippines in 2008 to that in 2009?
Provide a short and direct response. 0.93. What is the ratio of the Cost of computers, communications and other services (% of commerical service exports) of Iraq in 2008 to that in 2010?
Offer a very short reply. 0.34. What is the ratio of the Cost of computers, communications and other services (% of commerical service exports) in Philippines in 2008 to that in 2010?
Keep it short and to the point. 0.91. What is the ratio of the Cost of computers, communications and other services (% of commerical service exports) of Europe(developing only) in 2008 to that in 2011?
Keep it short and to the point. 0.96. What is the ratio of the Cost of computers, communications and other services (% of commerical service exports) in Iraq in 2008 to that in 2011?
Your response must be concise. 0.35. What is the ratio of the Cost of computers, communications and other services (% of commerical service exports) in Philippines in 2008 to that in 2011?
Provide a short and direct response. 0.93. What is the ratio of the Cost of computers, communications and other services (% of commerical service exports) of Europe(developing only) in 2008 to that in 2012?
Offer a terse response. 0.93. What is the ratio of the Cost of computers, communications and other services (% of commerical service exports) of Iraq in 2008 to that in 2012?
Keep it short and to the point. 0.16. What is the ratio of the Cost of computers, communications and other services (% of commerical service exports) in Philippines in 2008 to that in 2012?
Offer a very short reply. 0.97. What is the ratio of the Cost of computers, communications and other services (% of commerical service exports) of Europe(developing only) in 2009 to that in 2010?
Give a very brief answer. 0.98. What is the ratio of the Cost of computers, communications and other services (% of commerical service exports) of Iraq in 2009 to that in 2010?
Give a very brief answer. 0.65. What is the ratio of the Cost of computers, communications and other services (% of commerical service exports) of Philippines in 2009 to that in 2010?
Your response must be concise. 0.97. What is the ratio of the Cost of computers, communications and other services (% of commerical service exports) in Iraq in 2009 to that in 2011?
Offer a very short reply. 0.66. What is the ratio of the Cost of computers, communications and other services (% of commerical service exports) of Iraq in 2009 to that in 2012?
Provide a short and direct response. 0.3. What is the ratio of the Cost of computers, communications and other services (% of commerical service exports) in Philippines in 2009 to that in 2012?
Keep it short and to the point. 1.04. What is the ratio of the Cost of computers, communications and other services (% of commerical service exports) of Europe(developing only) in 2010 to that in 2011?
Provide a succinct answer. 1.02. What is the ratio of the Cost of computers, communications and other services (% of commerical service exports) of Iraq in 2010 to that in 2011?
Your response must be concise. 1.02. What is the ratio of the Cost of computers, communications and other services (% of commerical service exports) in Philippines in 2010 to that in 2011?
Make the answer very short. 1.03. What is the ratio of the Cost of computers, communications and other services (% of commerical service exports) of Europe(developing only) in 2010 to that in 2012?
Ensure brevity in your answer.  1. What is the ratio of the Cost of computers, communications and other services (% of commerical service exports) in Iraq in 2010 to that in 2012?
Ensure brevity in your answer.  0.47. What is the ratio of the Cost of computers, communications and other services (% of commerical service exports) of Philippines in 2010 to that in 2012?
Your answer should be very brief. 1.07. What is the ratio of the Cost of computers, communications and other services (% of commerical service exports) of Europe(developing only) in 2011 to that in 2012?
Offer a terse response. 0.97. What is the ratio of the Cost of computers, communications and other services (% of commerical service exports) in Iraq in 2011 to that in 2012?
Provide a succinct answer. 0.46. What is the ratio of the Cost of computers, communications and other services (% of commerical service exports) of Philippines in 2011 to that in 2012?
Your answer should be compact. 1.04. What is the difference between the highest and the second highest Cost of computers, communications and other services (% of commerical service exports) in Europe(developing only)?
Ensure brevity in your answer.  0.1. What is the difference between the highest and the second highest Cost of computers, communications and other services (% of commerical service exports) in Iraq?
Your answer should be compact. 6.83. What is the difference between the highest and the second highest Cost of computers, communications and other services (% of commerical service exports) in Philippines?
Provide a short and direct response. 1.95. What is the difference between the highest and the lowest Cost of computers, communications and other services (% of commerical service exports) in Europe(developing only)?
Keep it short and to the point. 2. What is the difference between the highest and the lowest Cost of computers, communications and other services (% of commerical service exports) in Iraq?
Your answer should be very brief. 12.65. What is the difference between the highest and the lowest Cost of computers, communications and other services (% of commerical service exports) in Philippines?
Offer a very short reply. 22.46. 